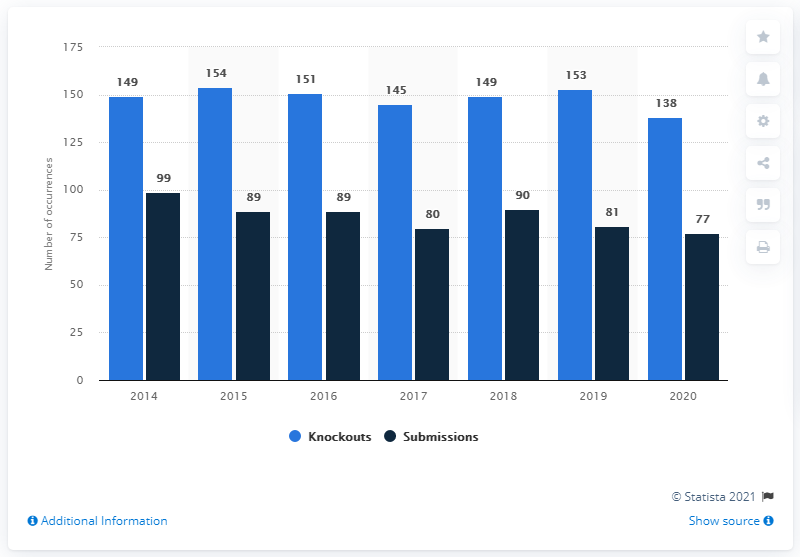Highlight a few significant elements in this photo. The number of fights took place in 2014. The tallest light blue bar is 55 and the tallest dark blue bar is also 55. The year 2014 had the highest number of knockouts and submissions occurrences in total. 